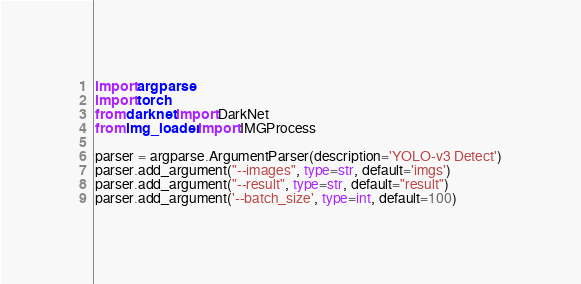<code> <loc_0><loc_0><loc_500><loc_500><_Python_>import argparse
import torch
from darknet import DarkNet
from img_loader import IMGProcess

parser = argparse.ArgumentParser(description='YOLO-v3 Detect')
parser.add_argument("--images", type=str, default='imgs')
parser.add_argument("--result", type=str, default="result")
parser.add_argument('--batch_size', type=int, default=100)</code> 